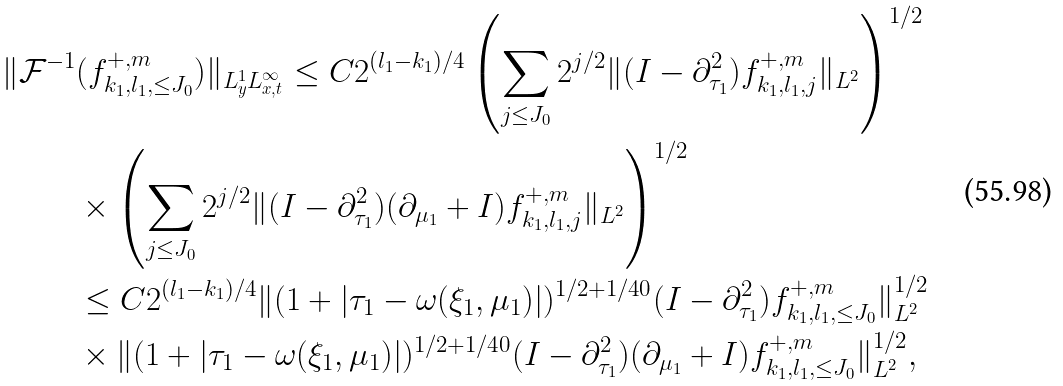Convert formula to latex. <formula><loc_0><loc_0><loc_500><loc_500>\| \mathcal { F } ^ { - 1 } & ( f _ { k _ { 1 } , l _ { 1 } , \leq J _ { 0 } } ^ { + , m } ) \| _ { L ^ { 1 } _ { y } L ^ { \infty } _ { x , t } } \leq C 2 ^ { ( l _ { 1 } - k _ { 1 } ) / 4 } \left ( \sum _ { j \leq J _ { 0 } } 2 ^ { j / 2 } \| ( I - \partial _ { \tau _ { 1 } } ^ { 2 } ) f _ { k _ { 1 } , l _ { 1 } , j } ^ { + , m } \| _ { L ^ { 2 } } \right ) ^ { 1 / 2 } \\ & \times \left ( \sum _ { j \leq J _ { 0 } } 2 ^ { j / 2 } \| ( I - \partial _ { \tau _ { 1 } } ^ { 2 } ) ( \partial _ { \mu _ { 1 } } + I ) f _ { k _ { 1 } , l _ { 1 } , j } ^ { + , m } \| _ { L ^ { 2 } } \right ) ^ { 1 / 2 } \\ & \leq C 2 ^ { ( l _ { 1 } - k _ { 1 } ) / 4 } \| ( 1 + | \tau _ { 1 } - \omega ( \xi _ { 1 } , \mu _ { 1 } ) | ) ^ { 1 / 2 + 1 / 4 0 } ( I - \partial _ { \tau _ { 1 } } ^ { 2 } ) f _ { k _ { 1 } , l _ { 1 } , \leq J _ { 0 } } ^ { + , m } \| _ { L ^ { 2 } } ^ { 1 / 2 } \\ & \times \| ( 1 + | \tau _ { 1 } - \omega ( \xi _ { 1 } , \mu _ { 1 } ) | ) ^ { 1 / 2 + 1 / 4 0 } ( I - \partial _ { \tau _ { 1 } } ^ { 2 } ) ( \partial _ { \mu _ { 1 } } + I ) f _ { k _ { 1 } , l _ { 1 } , \leq J _ { 0 } } ^ { + , m } \| _ { L ^ { 2 } } ^ { 1 / 2 } ,</formula> 